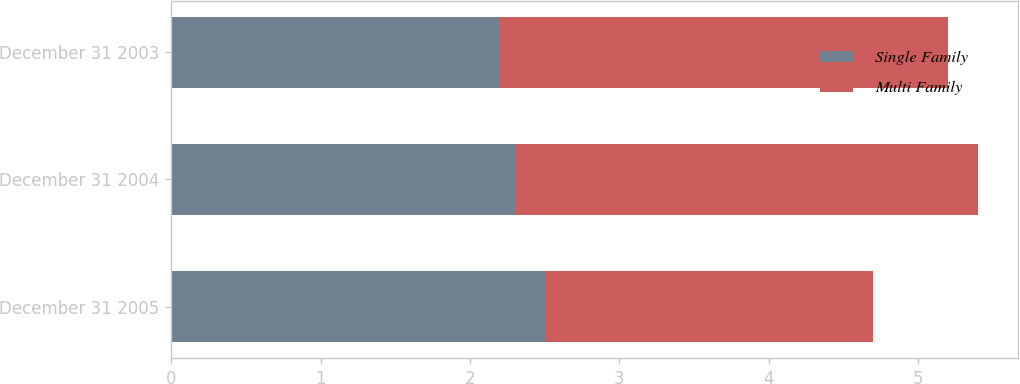Convert chart. <chart><loc_0><loc_0><loc_500><loc_500><stacked_bar_chart><ecel><fcel>December 31 2005<fcel>December 31 2004<fcel>December 31 2003<nl><fcel>Single Family<fcel>2.5<fcel>2.3<fcel>2.2<nl><fcel>Multi Family<fcel>2.2<fcel>3.1<fcel>3<nl></chart> 